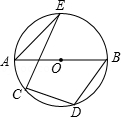First perform reasoning, then finally select the question from the choices in the following format: Answer: xxx.
Question: In the provided diagram, where AB is the diameter of circle O and points C, D, E lie on circle O, if angle AEC has a measurement of 20.0 degrees, what is the value of angle BDC?
Choices:
A: 100°
B: 110°
C: 115°
D: 120° Solution: As shown in the figure, connect BE. Since AB is the diameter, therefore angle AEB=90°. Given that angle AEC=20°, Therefore angle BEC=90°-20°=70°. Also, angle CDB+angle BEC=180°. Therefore, angle BDC=110°. Thus, the answer is B.
Answer:B 